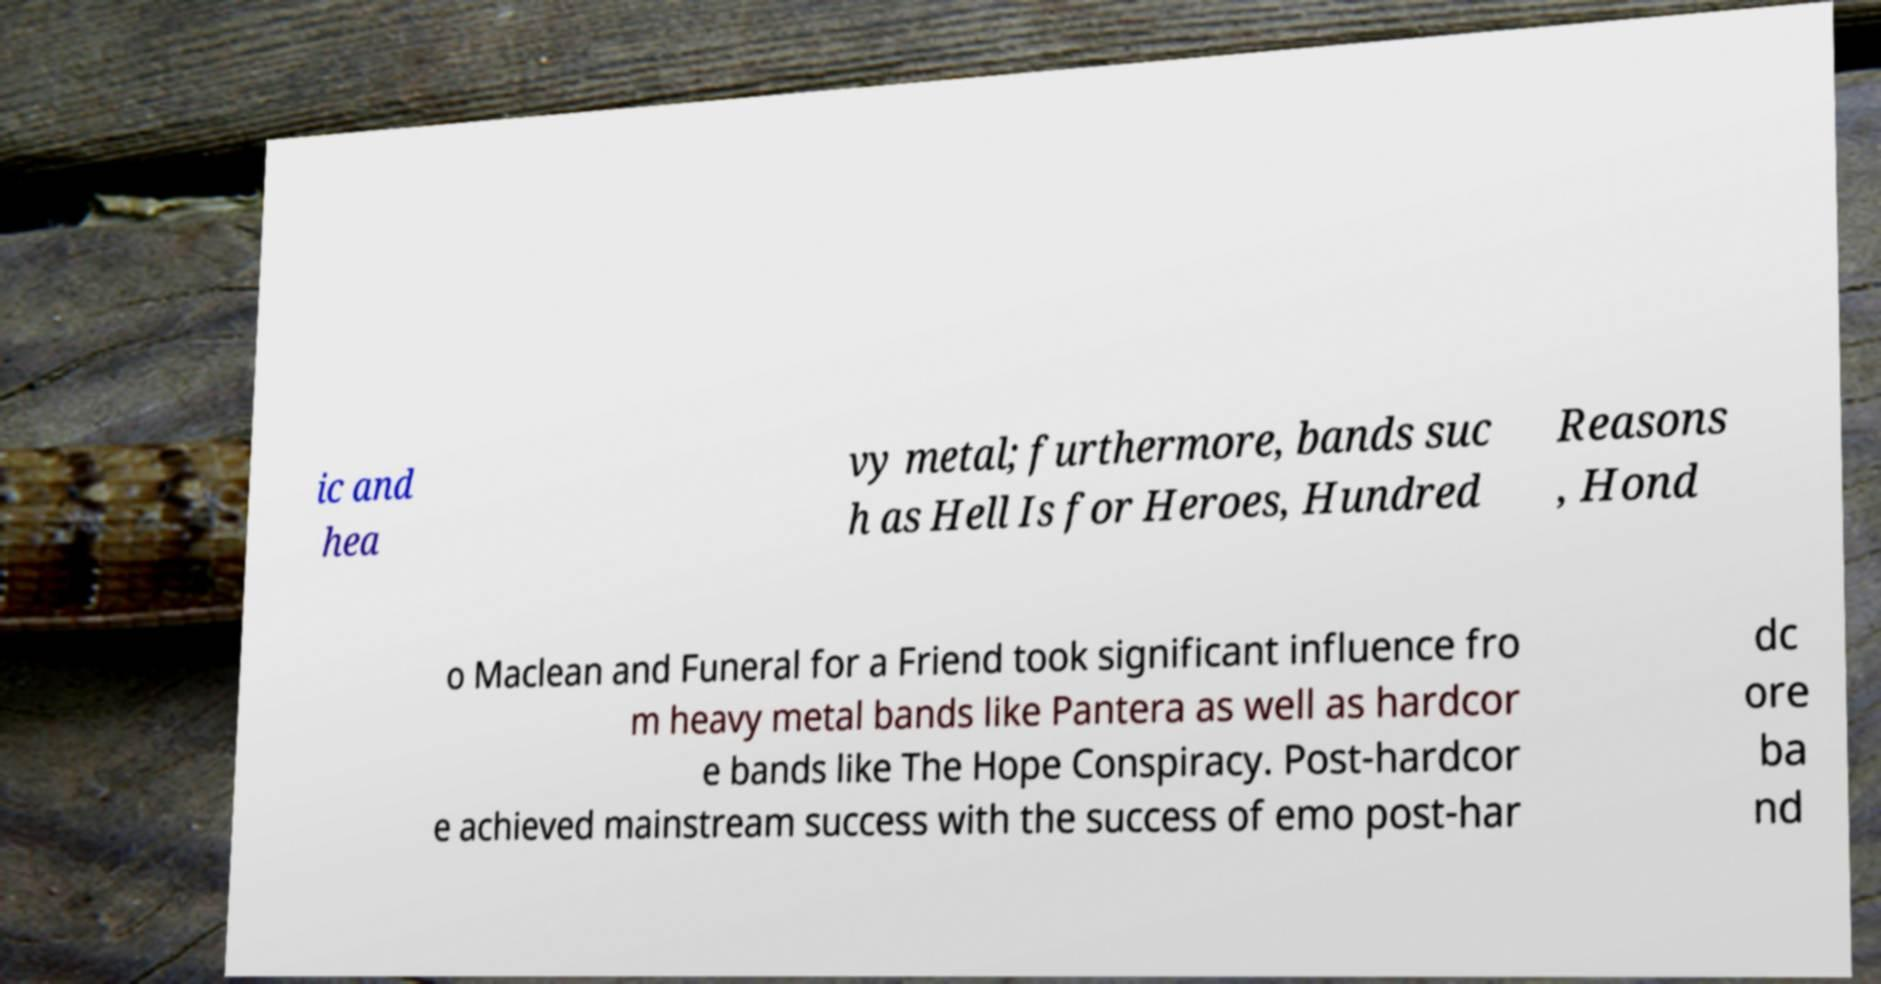Could you assist in decoding the text presented in this image and type it out clearly? ic and hea vy metal; furthermore, bands suc h as Hell Is for Heroes, Hundred Reasons , Hond o Maclean and Funeral for a Friend took significant influence fro m heavy metal bands like Pantera as well as hardcor e bands like The Hope Conspiracy. Post-hardcor e achieved mainstream success with the success of emo post-har dc ore ba nd 